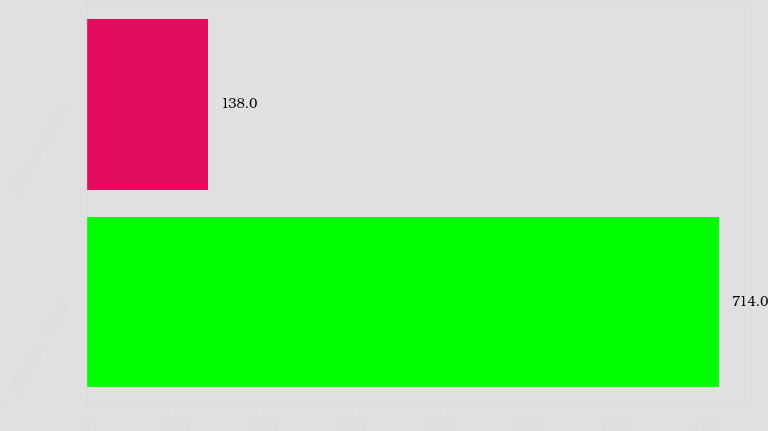<chart> <loc_0><loc_0><loc_500><loc_500><bar_chart><fcel>+ 200 bps shock<fcel>- 200 bps shock<nl><fcel>714<fcel>138<nl></chart> 